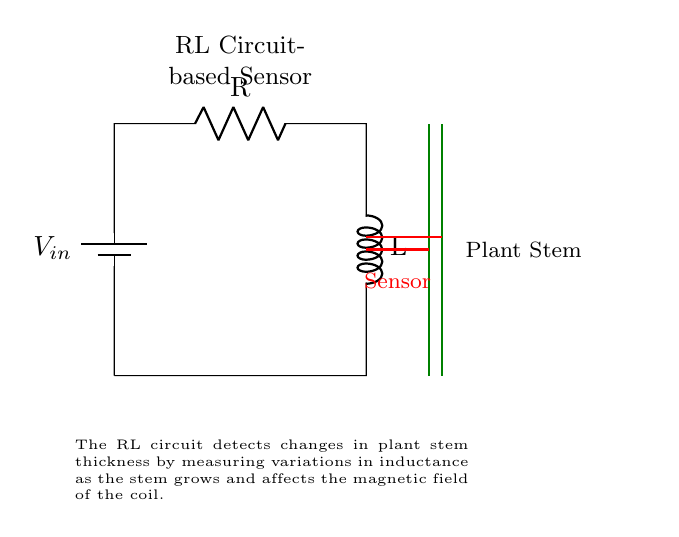What type of circuit is this? This is an RL circuit, which consists of a resistor and an inductor connected in series with a voltage source. The diagram shows clear indications of the resistor and inductor, confirming the circuit type.
Answer: RL circuit What does the green line represent? The green lines represent the plant stem in this diagram. They indicate where the sensor is measuring changes in thickness as the plant grows.
Answer: Plant stem What does the red line represent? The red lines in the circuit depict the sensor. This sensor is responsible for detecting changes in the inductance due to variations in plant stem thickness.
Answer: Sensor What component is connected in series with the resistor? The inductor is connected in series with the resistor in this circuit. This configuration allows the circuit to respond to changes in current over time, which is characteristic of RL circuits.
Answer: Inductor How does the circuit measure stem thickness? The circuit measures stem thickness by detecting variations in inductance as the stem grows, which affects the magnetic field around the coil of the inductor. The inductor's properties change as the plant grows, allowing for measurement.
Answer: By detecting variations in inductance What is the function of the resistor in this circuit? The resistor in an RL circuit controls the amount of current flowing through the circuit and affects the time constant of the response. It helps to limit current and determine the rate of any changes in the sensor's output.
Answer: Control current What indication does this circuit give when the stem grows? As the stem grows, the changes in thickness alter the inductance of the circuit, leading to measurable changes in the electrical properties of the circuit, such as voltage or current changes at the sensor output.
Answer: Changes in inductance 